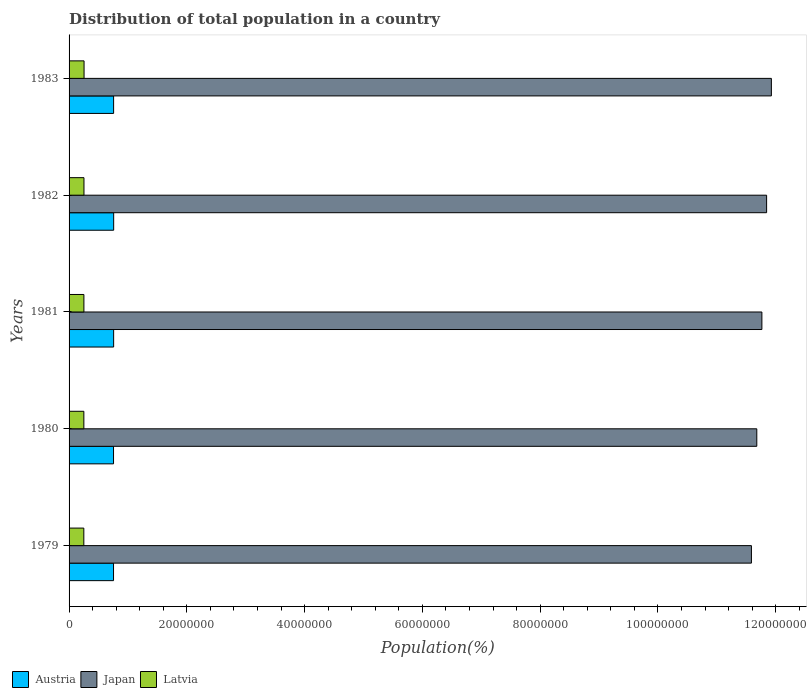How many different coloured bars are there?
Offer a terse response. 3. What is the population of in Japan in 1982?
Offer a very short reply. 1.18e+08. Across all years, what is the maximum population of in Japan?
Provide a short and direct response. 1.19e+08. Across all years, what is the minimum population of in Austria?
Give a very brief answer. 7.55e+06. In which year was the population of in Latvia maximum?
Provide a short and direct response. 1983. In which year was the population of in Latvia minimum?
Keep it short and to the point. 1979. What is the total population of in Latvia in the graph?
Your answer should be compact. 1.26e+07. What is the difference between the population of in Latvia in 1981 and that in 1983?
Offer a very short reply. -2.66e+04. What is the difference between the population of in Latvia in 1981 and the population of in Japan in 1983?
Your response must be concise. -1.17e+08. What is the average population of in Japan per year?
Ensure brevity in your answer.  1.18e+08. In the year 1983, what is the difference between the population of in Japan and population of in Austria?
Offer a terse response. 1.12e+08. In how many years, is the population of in Austria greater than 8000000 %?
Offer a very short reply. 0. What is the ratio of the population of in Japan in 1982 to that in 1983?
Your answer should be compact. 0.99. What is the difference between the highest and the second highest population of in Latvia?
Offer a terse response. 1.49e+04. What is the difference between the highest and the lowest population of in Latvia?
Make the answer very short. 4.01e+04. What does the 1st bar from the bottom in 1981 represents?
Your response must be concise. Austria. Is it the case that in every year, the sum of the population of in Japan and population of in Austria is greater than the population of in Latvia?
Your answer should be very brief. Yes. How many bars are there?
Offer a terse response. 15. Does the graph contain grids?
Give a very brief answer. No. Where does the legend appear in the graph?
Your answer should be compact. Bottom left. How are the legend labels stacked?
Offer a terse response. Horizontal. What is the title of the graph?
Your answer should be very brief. Distribution of total population in a country. What is the label or title of the X-axis?
Offer a terse response. Population(%). What is the label or title of the Y-axis?
Make the answer very short. Years. What is the Population(%) in Austria in 1979?
Your answer should be compact. 7.55e+06. What is the Population(%) of Japan in 1979?
Your response must be concise. 1.16e+08. What is the Population(%) in Latvia in 1979?
Keep it short and to the point. 2.51e+06. What is the Population(%) in Austria in 1980?
Keep it short and to the point. 7.55e+06. What is the Population(%) of Japan in 1980?
Offer a very short reply. 1.17e+08. What is the Population(%) of Latvia in 1980?
Offer a terse response. 2.51e+06. What is the Population(%) in Austria in 1981?
Provide a succinct answer. 7.57e+06. What is the Population(%) in Japan in 1981?
Ensure brevity in your answer.  1.18e+08. What is the Population(%) of Latvia in 1981?
Offer a very short reply. 2.52e+06. What is the Population(%) of Austria in 1982?
Keep it short and to the point. 7.57e+06. What is the Population(%) in Japan in 1982?
Your response must be concise. 1.18e+08. What is the Population(%) in Latvia in 1982?
Make the answer very short. 2.53e+06. What is the Population(%) of Austria in 1983?
Offer a terse response. 7.56e+06. What is the Population(%) in Japan in 1983?
Your answer should be compact. 1.19e+08. What is the Population(%) in Latvia in 1983?
Provide a succinct answer. 2.55e+06. Across all years, what is the maximum Population(%) of Austria?
Provide a short and direct response. 7.57e+06. Across all years, what is the maximum Population(%) in Japan?
Give a very brief answer. 1.19e+08. Across all years, what is the maximum Population(%) in Latvia?
Your answer should be compact. 2.55e+06. Across all years, what is the minimum Population(%) in Austria?
Your response must be concise. 7.55e+06. Across all years, what is the minimum Population(%) in Japan?
Keep it short and to the point. 1.16e+08. Across all years, what is the minimum Population(%) of Latvia?
Offer a very short reply. 2.51e+06. What is the total Population(%) in Austria in the graph?
Ensure brevity in your answer.  3.78e+07. What is the total Population(%) of Japan in the graph?
Your answer should be compact. 5.88e+08. What is the total Population(%) of Latvia in the graph?
Your answer should be very brief. 1.26e+07. What is the difference between the Population(%) in Japan in 1979 and that in 1980?
Make the answer very short. -9.12e+05. What is the difference between the Population(%) of Latvia in 1979 and that in 1980?
Ensure brevity in your answer.  -5748. What is the difference between the Population(%) of Austria in 1979 and that in 1981?
Your answer should be very brief. -1.93e+04. What is the difference between the Population(%) of Japan in 1979 and that in 1981?
Give a very brief answer. -1.78e+06. What is the difference between the Population(%) in Latvia in 1979 and that in 1981?
Your answer should be compact. -1.35e+04. What is the difference between the Population(%) of Austria in 1979 and that in 1982?
Provide a succinct answer. -2.47e+04. What is the difference between the Population(%) in Japan in 1979 and that in 1982?
Ensure brevity in your answer.  -2.58e+06. What is the difference between the Population(%) in Latvia in 1979 and that in 1982?
Ensure brevity in your answer.  -2.51e+04. What is the difference between the Population(%) in Austria in 1979 and that in 1983?
Your answer should be very brief. -1.25e+04. What is the difference between the Population(%) in Japan in 1979 and that in 1983?
Provide a succinct answer. -3.39e+06. What is the difference between the Population(%) in Latvia in 1979 and that in 1983?
Your answer should be very brief. -4.01e+04. What is the difference between the Population(%) of Austria in 1980 and that in 1981?
Offer a very short reply. -1.93e+04. What is the difference between the Population(%) in Japan in 1980 and that in 1981?
Ensure brevity in your answer.  -8.66e+05. What is the difference between the Population(%) in Latvia in 1980 and that in 1981?
Your answer should be compact. -7720. What is the difference between the Population(%) of Austria in 1980 and that in 1982?
Make the answer very short. -2.47e+04. What is the difference between the Population(%) in Japan in 1980 and that in 1982?
Your answer should be very brief. -1.67e+06. What is the difference between the Population(%) in Latvia in 1980 and that in 1982?
Provide a succinct answer. -1.94e+04. What is the difference between the Population(%) of Austria in 1980 and that in 1983?
Provide a short and direct response. -1.25e+04. What is the difference between the Population(%) of Japan in 1980 and that in 1983?
Offer a very short reply. -2.48e+06. What is the difference between the Population(%) in Latvia in 1980 and that in 1983?
Offer a very short reply. -3.43e+04. What is the difference between the Population(%) in Austria in 1981 and that in 1982?
Provide a short and direct response. -5430. What is the difference between the Population(%) of Japan in 1981 and that in 1982?
Ensure brevity in your answer.  -8.01e+05. What is the difference between the Population(%) of Latvia in 1981 and that in 1982?
Offer a terse response. -1.17e+04. What is the difference between the Population(%) in Austria in 1981 and that in 1983?
Your answer should be very brief. 6800. What is the difference between the Population(%) of Japan in 1981 and that in 1983?
Give a very brief answer. -1.61e+06. What is the difference between the Population(%) in Latvia in 1981 and that in 1983?
Your response must be concise. -2.66e+04. What is the difference between the Population(%) in Austria in 1982 and that in 1983?
Make the answer very short. 1.22e+04. What is the difference between the Population(%) in Japan in 1982 and that in 1983?
Ensure brevity in your answer.  -8.10e+05. What is the difference between the Population(%) in Latvia in 1982 and that in 1983?
Make the answer very short. -1.49e+04. What is the difference between the Population(%) of Austria in 1979 and the Population(%) of Japan in 1980?
Give a very brief answer. -1.09e+08. What is the difference between the Population(%) of Austria in 1979 and the Population(%) of Latvia in 1980?
Provide a succinct answer. 5.04e+06. What is the difference between the Population(%) in Japan in 1979 and the Population(%) in Latvia in 1980?
Provide a succinct answer. 1.13e+08. What is the difference between the Population(%) in Austria in 1979 and the Population(%) in Japan in 1981?
Offer a terse response. -1.10e+08. What is the difference between the Population(%) of Austria in 1979 and the Population(%) of Latvia in 1981?
Your response must be concise. 5.03e+06. What is the difference between the Population(%) in Japan in 1979 and the Population(%) in Latvia in 1981?
Keep it short and to the point. 1.13e+08. What is the difference between the Population(%) of Austria in 1979 and the Population(%) of Japan in 1982?
Keep it short and to the point. -1.11e+08. What is the difference between the Population(%) in Austria in 1979 and the Population(%) in Latvia in 1982?
Offer a very short reply. 5.02e+06. What is the difference between the Population(%) in Japan in 1979 and the Population(%) in Latvia in 1982?
Keep it short and to the point. 1.13e+08. What is the difference between the Population(%) of Austria in 1979 and the Population(%) of Japan in 1983?
Make the answer very short. -1.12e+08. What is the difference between the Population(%) in Austria in 1979 and the Population(%) in Latvia in 1983?
Offer a terse response. 5.00e+06. What is the difference between the Population(%) in Japan in 1979 and the Population(%) in Latvia in 1983?
Your answer should be compact. 1.13e+08. What is the difference between the Population(%) in Austria in 1980 and the Population(%) in Japan in 1981?
Give a very brief answer. -1.10e+08. What is the difference between the Population(%) in Austria in 1980 and the Population(%) in Latvia in 1981?
Offer a terse response. 5.03e+06. What is the difference between the Population(%) of Japan in 1980 and the Population(%) of Latvia in 1981?
Make the answer very short. 1.14e+08. What is the difference between the Population(%) in Austria in 1980 and the Population(%) in Japan in 1982?
Offer a terse response. -1.11e+08. What is the difference between the Population(%) in Austria in 1980 and the Population(%) in Latvia in 1982?
Your answer should be very brief. 5.02e+06. What is the difference between the Population(%) of Japan in 1980 and the Population(%) of Latvia in 1982?
Your response must be concise. 1.14e+08. What is the difference between the Population(%) of Austria in 1980 and the Population(%) of Japan in 1983?
Provide a succinct answer. -1.12e+08. What is the difference between the Population(%) in Austria in 1980 and the Population(%) in Latvia in 1983?
Provide a succinct answer. 5.00e+06. What is the difference between the Population(%) of Japan in 1980 and the Population(%) of Latvia in 1983?
Offer a terse response. 1.14e+08. What is the difference between the Population(%) of Austria in 1981 and the Population(%) of Japan in 1982?
Ensure brevity in your answer.  -1.11e+08. What is the difference between the Population(%) in Austria in 1981 and the Population(%) in Latvia in 1982?
Offer a terse response. 5.04e+06. What is the difference between the Population(%) in Japan in 1981 and the Population(%) in Latvia in 1982?
Make the answer very short. 1.15e+08. What is the difference between the Population(%) of Austria in 1981 and the Population(%) of Japan in 1983?
Provide a short and direct response. -1.12e+08. What is the difference between the Population(%) in Austria in 1981 and the Population(%) in Latvia in 1983?
Offer a very short reply. 5.02e+06. What is the difference between the Population(%) of Japan in 1981 and the Population(%) of Latvia in 1983?
Offer a terse response. 1.15e+08. What is the difference between the Population(%) of Austria in 1982 and the Population(%) of Japan in 1983?
Ensure brevity in your answer.  -1.12e+08. What is the difference between the Population(%) in Austria in 1982 and the Population(%) in Latvia in 1983?
Make the answer very short. 5.03e+06. What is the difference between the Population(%) in Japan in 1982 and the Population(%) in Latvia in 1983?
Provide a short and direct response. 1.16e+08. What is the average Population(%) of Austria per year?
Ensure brevity in your answer.  7.56e+06. What is the average Population(%) of Japan per year?
Provide a short and direct response. 1.18e+08. What is the average Population(%) of Latvia per year?
Offer a terse response. 2.52e+06. In the year 1979, what is the difference between the Population(%) of Austria and Population(%) of Japan?
Your answer should be compact. -1.08e+08. In the year 1979, what is the difference between the Population(%) of Austria and Population(%) of Latvia?
Provide a succinct answer. 5.04e+06. In the year 1979, what is the difference between the Population(%) of Japan and Population(%) of Latvia?
Offer a terse response. 1.13e+08. In the year 1980, what is the difference between the Population(%) of Austria and Population(%) of Japan?
Offer a very short reply. -1.09e+08. In the year 1980, what is the difference between the Population(%) of Austria and Population(%) of Latvia?
Offer a terse response. 5.04e+06. In the year 1980, what is the difference between the Population(%) in Japan and Population(%) in Latvia?
Your answer should be very brief. 1.14e+08. In the year 1981, what is the difference between the Population(%) in Austria and Population(%) in Japan?
Ensure brevity in your answer.  -1.10e+08. In the year 1981, what is the difference between the Population(%) of Austria and Population(%) of Latvia?
Keep it short and to the point. 5.05e+06. In the year 1981, what is the difference between the Population(%) in Japan and Population(%) in Latvia?
Your answer should be very brief. 1.15e+08. In the year 1982, what is the difference between the Population(%) of Austria and Population(%) of Japan?
Your response must be concise. -1.11e+08. In the year 1982, what is the difference between the Population(%) in Austria and Population(%) in Latvia?
Your answer should be very brief. 5.04e+06. In the year 1982, what is the difference between the Population(%) in Japan and Population(%) in Latvia?
Keep it short and to the point. 1.16e+08. In the year 1983, what is the difference between the Population(%) of Austria and Population(%) of Japan?
Provide a succinct answer. -1.12e+08. In the year 1983, what is the difference between the Population(%) in Austria and Population(%) in Latvia?
Your answer should be compact. 5.02e+06. In the year 1983, what is the difference between the Population(%) in Japan and Population(%) in Latvia?
Provide a succinct answer. 1.17e+08. What is the ratio of the Population(%) in Austria in 1979 to that in 1981?
Your response must be concise. 1. What is the ratio of the Population(%) of Japan in 1979 to that in 1981?
Your response must be concise. 0.98. What is the ratio of the Population(%) in Latvia in 1979 to that in 1981?
Your answer should be very brief. 0.99. What is the ratio of the Population(%) of Austria in 1979 to that in 1982?
Your answer should be compact. 1. What is the ratio of the Population(%) of Japan in 1979 to that in 1982?
Provide a short and direct response. 0.98. What is the ratio of the Population(%) in Latvia in 1979 to that in 1982?
Give a very brief answer. 0.99. What is the ratio of the Population(%) of Austria in 1979 to that in 1983?
Offer a very short reply. 1. What is the ratio of the Population(%) in Japan in 1979 to that in 1983?
Offer a very short reply. 0.97. What is the ratio of the Population(%) of Latvia in 1979 to that in 1983?
Provide a succinct answer. 0.98. What is the ratio of the Population(%) of Latvia in 1980 to that in 1981?
Make the answer very short. 1. What is the ratio of the Population(%) of Japan in 1980 to that in 1982?
Provide a short and direct response. 0.99. What is the ratio of the Population(%) of Austria in 1980 to that in 1983?
Offer a terse response. 1. What is the ratio of the Population(%) in Japan in 1980 to that in 1983?
Your answer should be compact. 0.98. What is the ratio of the Population(%) in Latvia in 1980 to that in 1983?
Your answer should be very brief. 0.99. What is the ratio of the Population(%) of Latvia in 1981 to that in 1982?
Provide a short and direct response. 1. What is the ratio of the Population(%) of Austria in 1981 to that in 1983?
Provide a succinct answer. 1. What is the ratio of the Population(%) of Japan in 1981 to that in 1983?
Offer a terse response. 0.99. What is the ratio of the Population(%) in Latvia in 1981 to that in 1983?
Provide a succinct answer. 0.99. What is the ratio of the Population(%) in Japan in 1982 to that in 1983?
Make the answer very short. 0.99. What is the difference between the highest and the second highest Population(%) of Austria?
Offer a very short reply. 5430. What is the difference between the highest and the second highest Population(%) of Japan?
Keep it short and to the point. 8.10e+05. What is the difference between the highest and the second highest Population(%) of Latvia?
Your response must be concise. 1.49e+04. What is the difference between the highest and the lowest Population(%) of Austria?
Offer a very short reply. 2.47e+04. What is the difference between the highest and the lowest Population(%) of Japan?
Provide a short and direct response. 3.39e+06. What is the difference between the highest and the lowest Population(%) in Latvia?
Your answer should be very brief. 4.01e+04. 